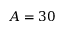Convert formula to latex. <formula><loc_0><loc_0><loc_500><loc_500>A = 3 0</formula> 